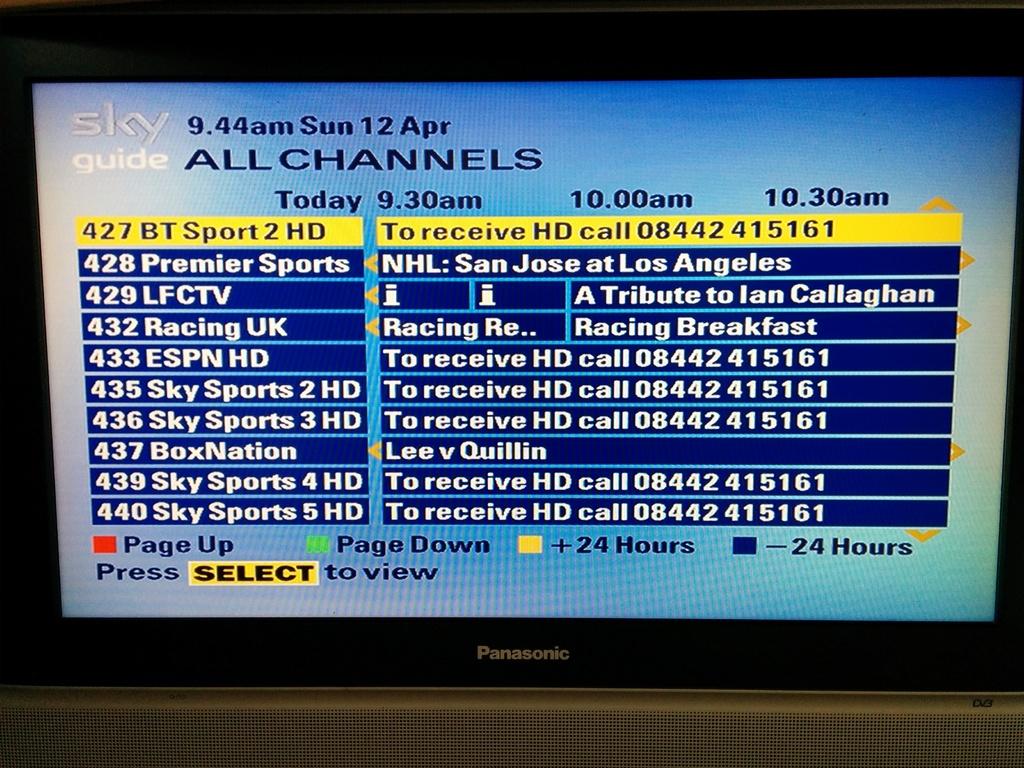What is the brand of this tv?
Make the answer very short. Panasonic. 